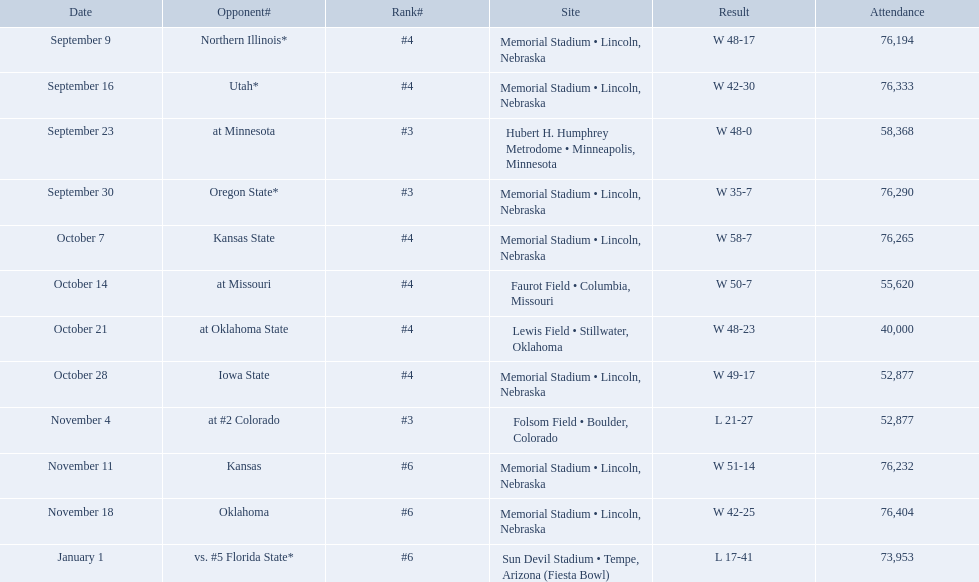Which opponenets did the nebraska cornhuskers score fewer than 40 points against? Oregon State*, at #2 Colorado, vs. #5 Florida State*. Of these games, which ones had an attendance of greater than 70,000? Oregon State*, vs. #5 Florida State*. Which of these opponents did they beat? Oregon State*. How many people were in attendance at that game? 76,290. When did the match between nebraska and oregon state occur? September 30. What was the crowd size at the september 30 event? 76,290. Which rival teams did the nebraska cornhuskers score 40 points or less against? Oregon State*, at #2 Colorado, vs. #5 Florida State*. Out of these games, which ones had an audience of 70,000 or more? Oregon State*, vs. #5 Florida State*. Which of these opponents were beaten by the cornhuskers? Oregon State*. What was the number of people in attendance for that game? 76,290. 